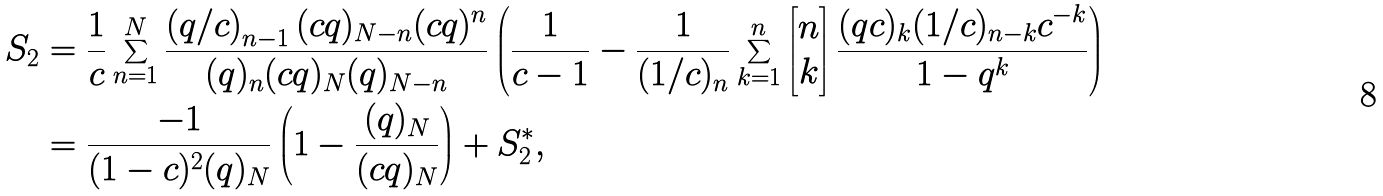Convert formula to latex. <formula><loc_0><loc_0><loc_500><loc_500>S _ { 2 } & = \frac { 1 } { c } \sum _ { n = 1 } ^ { N } \frac { \left ( q / c \right ) _ { n - 1 } ( c q ) _ { N - n } ( c q ) ^ { n } } { ( q ) _ { n } ( c q ) _ { N } ( q ) _ { N - n } } \left ( \frac { 1 } { c - 1 } - \frac { 1 } { ( 1 / c ) _ { n } } \sum _ { k = 1 } ^ { n } \left [ \begin{matrix} n \\ k \end{matrix} \right ] \frac { ( q c ) _ { k } ( 1 / c ) _ { n - k } c ^ { - k } } { 1 - q ^ { k } } \right ) \\ & = \frac { - 1 } { ( 1 - c ) ^ { 2 } ( q ) _ { N } } \left ( 1 - \frac { ( q ) _ { N } } { ( c q ) _ { N } } \right ) + S _ { 2 } ^ { * } ,</formula> 